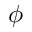Convert formula to latex. <formula><loc_0><loc_0><loc_500><loc_500>\phi</formula> 